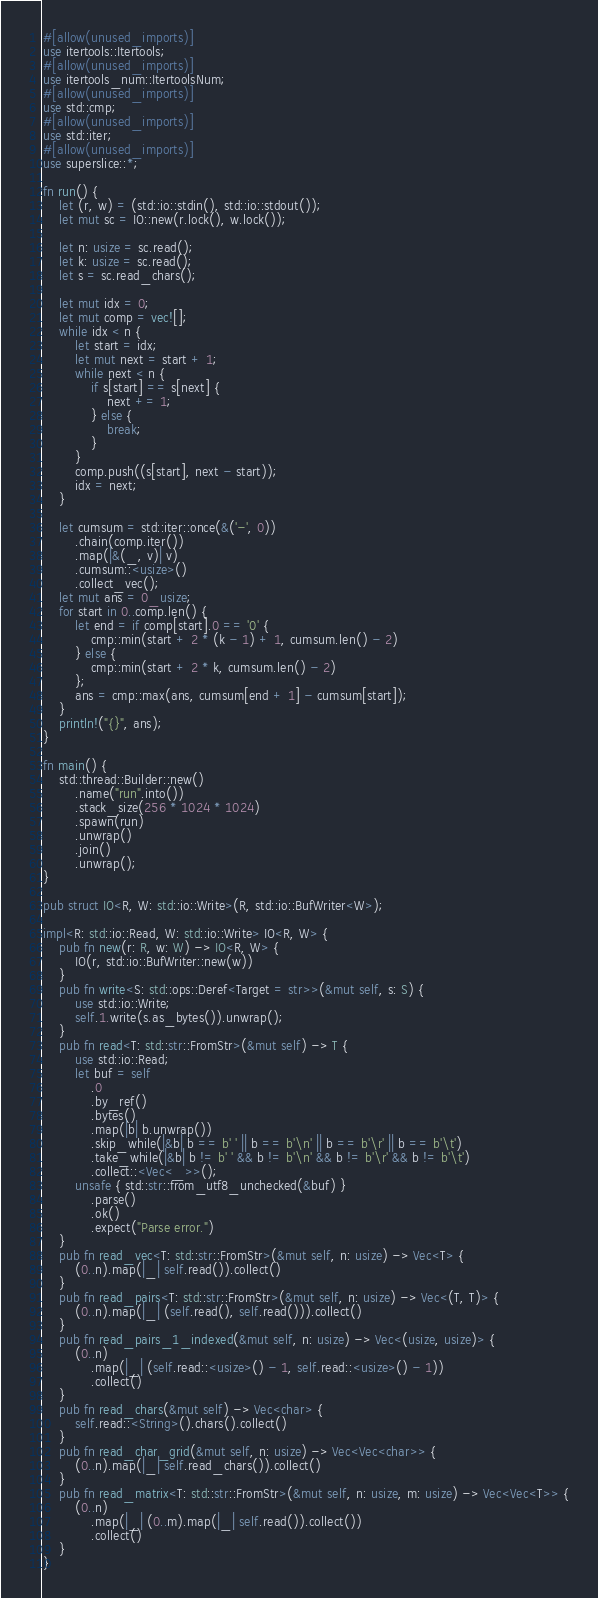<code> <loc_0><loc_0><loc_500><loc_500><_Rust_>#[allow(unused_imports)]
use itertools::Itertools;
#[allow(unused_imports)]
use itertools_num::ItertoolsNum;
#[allow(unused_imports)]
use std::cmp;
#[allow(unused_imports)]
use std::iter;
#[allow(unused_imports)]
use superslice::*;

fn run() {
    let (r, w) = (std::io::stdin(), std::io::stdout());
    let mut sc = IO::new(r.lock(), w.lock());

    let n: usize = sc.read();
    let k: usize = sc.read();
    let s = sc.read_chars();

    let mut idx = 0;
    let mut comp = vec![];
    while idx < n {
        let start = idx;
        let mut next = start + 1;
        while next < n {
            if s[start] == s[next] {
                next += 1;
            } else {
                break;
            }
        }
        comp.push((s[start], next - start));
        idx = next;
    }

    let cumsum = std::iter::once(&('-', 0))
        .chain(comp.iter())
        .map(|&(_, v)| v)
        .cumsum::<usize>()
        .collect_vec();
    let mut ans = 0_usize;
    for start in 0..comp.len() {
        let end = if comp[start].0 == '0' {
            cmp::min(start + 2 * (k - 1) + 1, cumsum.len() - 2)
        } else {
            cmp::min(start + 2 * k, cumsum.len() - 2)
        };
        ans = cmp::max(ans, cumsum[end + 1] - cumsum[start]);
    }
    println!("{}", ans);
}

fn main() {
    std::thread::Builder::new()
        .name("run".into())
        .stack_size(256 * 1024 * 1024)
        .spawn(run)
        .unwrap()
        .join()
        .unwrap();
}

pub struct IO<R, W: std::io::Write>(R, std::io::BufWriter<W>);

impl<R: std::io::Read, W: std::io::Write> IO<R, W> {
    pub fn new(r: R, w: W) -> IO<R, W> {
        IO(r, std::io::BufWriter::new(w))
    }
    pub fn write<S: std::ops::Deref<Target = str>>(&mut self, s: S) {
        use std::io::Write;
        self.1.write(s.as_bytes()).unwrap();
    }
    pub fn read<T: std::str::FromStr>(&mut self) -> T {
        use std::io::Read;
        let buf = self
            .0
            .by_ref()
            .bytes()
            .map(|b| b.unwrap())
            .skip_while(|&b| b == b' ' || b == b'\n' || b == b'\r' || b == b'\t')
            .take_while(|&b| b != b' ' && b != b'\n' && b != b'\r' && b != b'\t')
            .collect::<Vec<_>>();
        unsafe { std::str::from_utf8_unchecked(&buf) }
            .parse()
            .ok()
            .expect("Parse error.")
    }
    pub fn read_vec<T: std::str::FromStr>(&mut self, n: usize) -> Vec<T> {
        (0..n).map(|_| self.read()).collect()
    }
    pub fn read_pairs<T: std::str::FromStr>(&mut self, n: usize) -> Vec<(T, T)> {
        (0..n).map(|_| (self.read(), self.read())).collect()
    }
    pub fn read_pairs_1_indexed(&mut self, n: usize) -> Vec<(usize, usize)> {
        (0..n)
            .map(|_| (self.read::<usize>() - 1, self.read::<usize>() - 1))
            .collect()
    }
    pub fn read_chars(&mut self) -> Vec<char> {
        self.read::<String>().chars().collect()
    }
    pub fn read_char_grid(&mut self, n: usize) -> Vec<Vec<char>> {
        (0..n).map(|_| self.read_chars()).collect()
    }
    pub fn read_matrix<T: std::str::FromStr>(&mut self, n: usize, m: usize) -> Vec<Vec<T>> {
        (0..n)
            .map(|_| (0..m).map(|_| self.read()).collect())
            .collect()
    }
}
</code> 